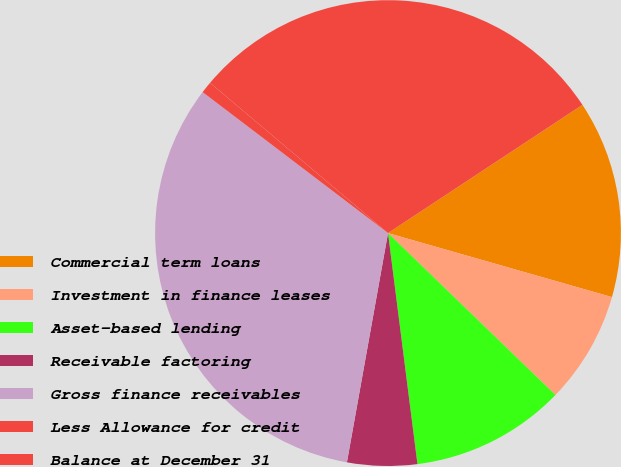Convert chart. <chart><loc_0><loc_0><loc_500><loc_500><pie_chart><fcel>Commercial term loans<fcel>Investment in finance leases<fcel>Asset-based lending<fcel>Receivable factoring<fcel>Gross finance receivables<fcel>Less Allowance for credit<fcel>Balance at December 31<nl><fcel>13.71%<fcel>7.8%<fcel>10.75%<fcel>4.84%<fcel>32.52%<fcel>0.81%<fcel>29.56%<nl></chart> 